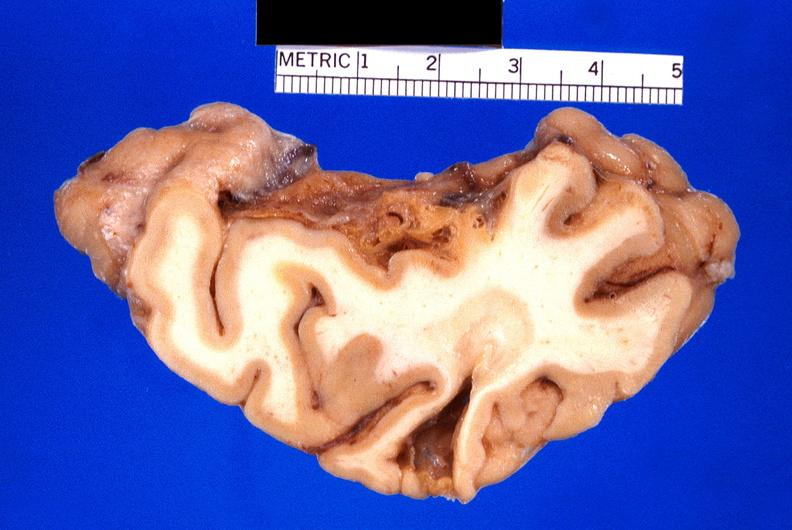s normal present?
Answer the question using a single word or phrase. No 